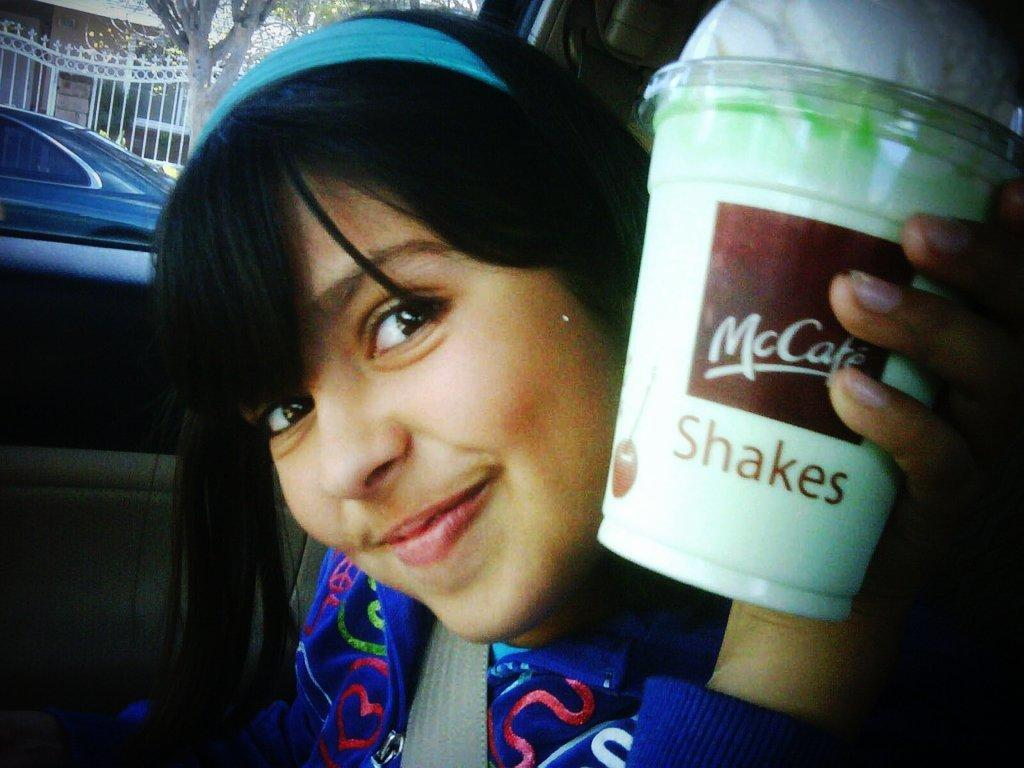Who is present in the image? There is a woman in the image. What is the woman doing in the image? The woman is smiling in the image. What is the woman holding in her hand? The woman is holding a disposable tumbler in her hand. What can be seen in the background of the image? There are trees, grills, a building, and a motor vehicle in the background of the image. Where is the goat located in the image? There is no goat present in the image. What type of shirt is the woman wearing in the image? The provided facts do not mention the type of shirt the woman is wearing, so we cannot answer this question definitively. 